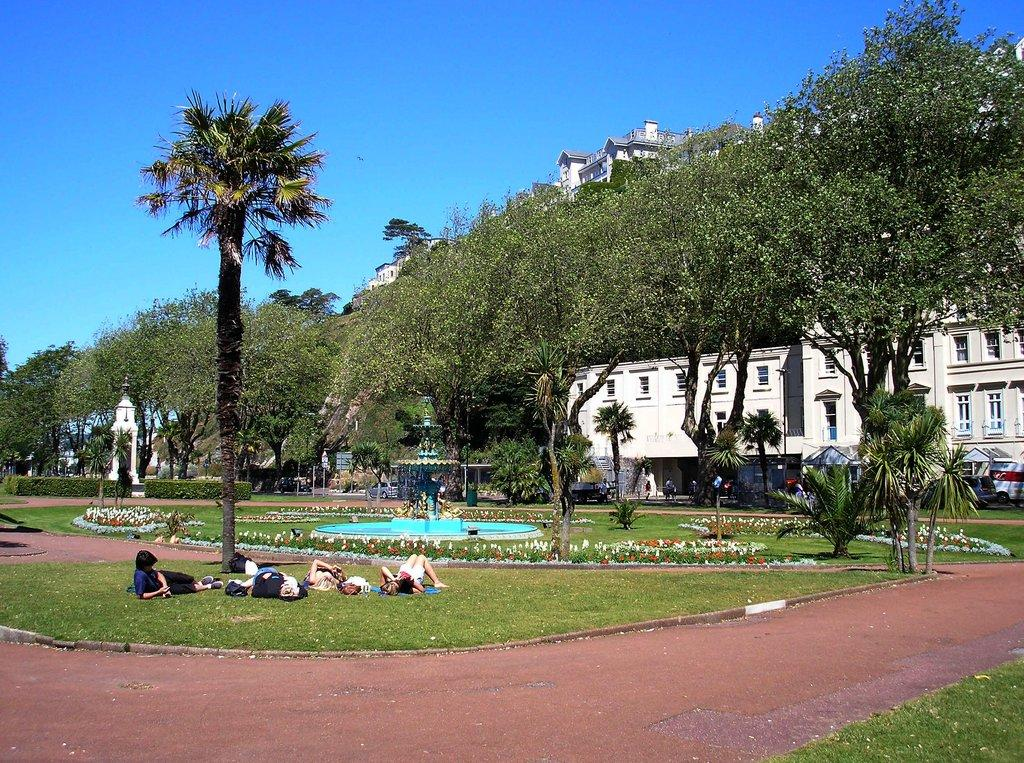What are the people in the image doing? The people in the image are lying on the grass. What type of vegetation is present in the image? There are trees in the image. What is the water feature in the image? There is a fountain in the image. What structure is located on the right side of the image? There is a building on the right side of the image. What is the condition of the sky in the image? The sky is clear in the image. What type of reaction can be seen from the cub in the image? There is no cub present in the image, so no reaction can be observed. What type of beds are visible in the image? There are no beds present in the image. 